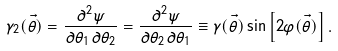Convert formula to latex. <formula><loc_0><loc_0><loc_500><loc_500>\gamma _ { 2 } ( \vec { \theta } ) = \frac { \partial ^ { 2 } \psi } { \partial \theta _ { 1 } \partial \theta _ { 2 } } = \frac { \partial ^ { 2 } \psi } { \partial \theta _ { 2 } \partial \theta _ { 1 } } \equiv \gamma ( \vec { \theta } ) \sin \left [ 2 \varphi ( \vec { \theta } ) \right ] .</formula> 